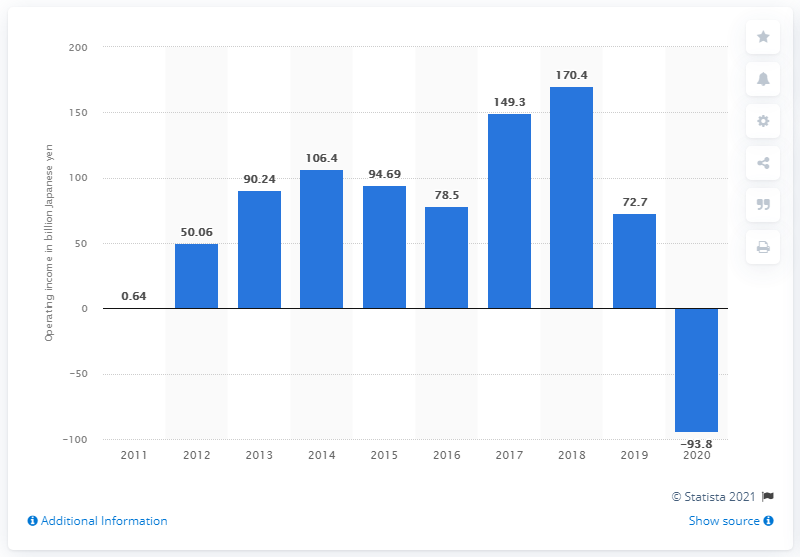Give some essential details in this illustration. The Rakuten Group earned 72.7 billion yen in the previous fiscal year. The operating loss of the Rakuten Group in fiscal year 2020 was 94.69. 